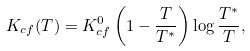<formula> <loc_0><loc_0><loc_500><loc_500>K _ { c f } ( T ) = K _ { c f } ^ { 0 } \left ( 1 - \frac { T } { T ^ { \ast } } \right ) \log \frac { T ^ { \ast } } { T } ,</formula> 